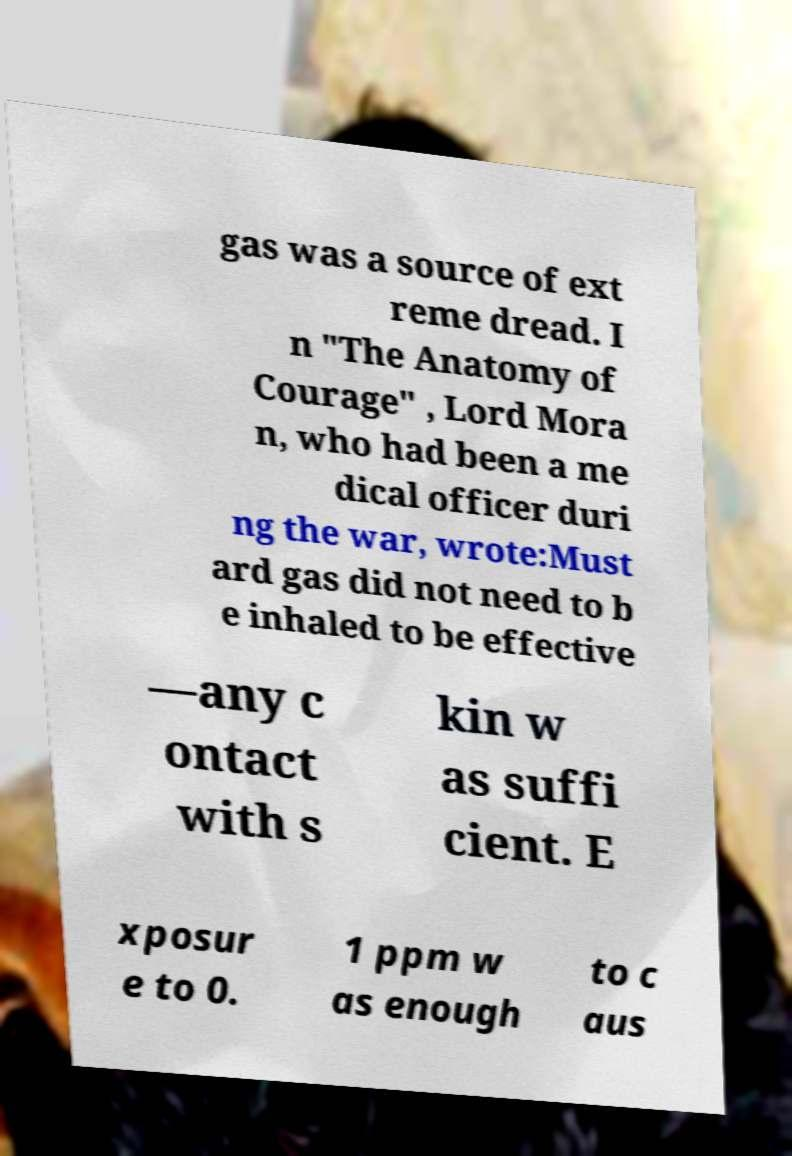Can you read and provide the text displayed in the image?This photo seems to have some interesting text. Can you extract and type it out for me? gas was a source of ext reme dread. I n "The Anatomy of Courage" , Lord Mora n, who had been a me dical officer duri ng the war, wrote:Must ard gas did not need to b e inhaled to be effective —any c ontact with s kin w as suffi cient. E xposur e to 0. 1 ppm w as enough to c aus 